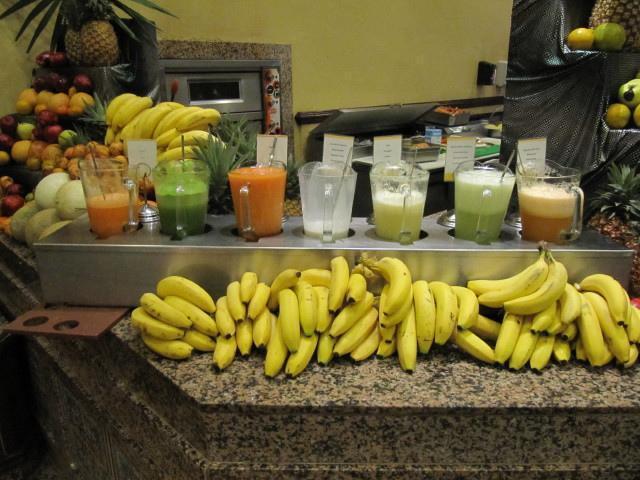How many beverages are there?
Give a very brief answer. 7. How many cups are there?
Give a very brief answer. 7. How many bananas are in the photo?
Give a very brief answer. 8. How many ovens are in the picture?
Give a very brief answer. 1. 